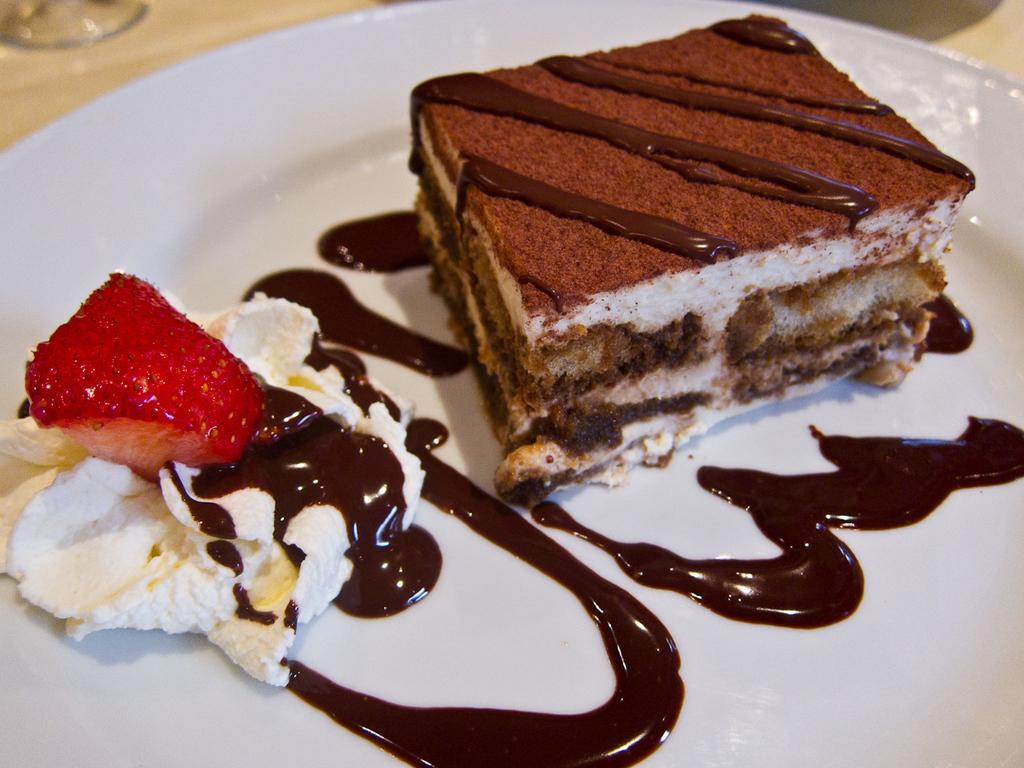What type of dessert is visible in the image? There is a piece of cake in the image. What else is present on the plate with the cake? There is sauce on the left side of the image. What color is the plate that holds the cake and sauce? The plate is white in color. Can you tell me how many times the person in the image sneezes? There is no person present in the image, so it is not possible to determine how many times they sneeze. 